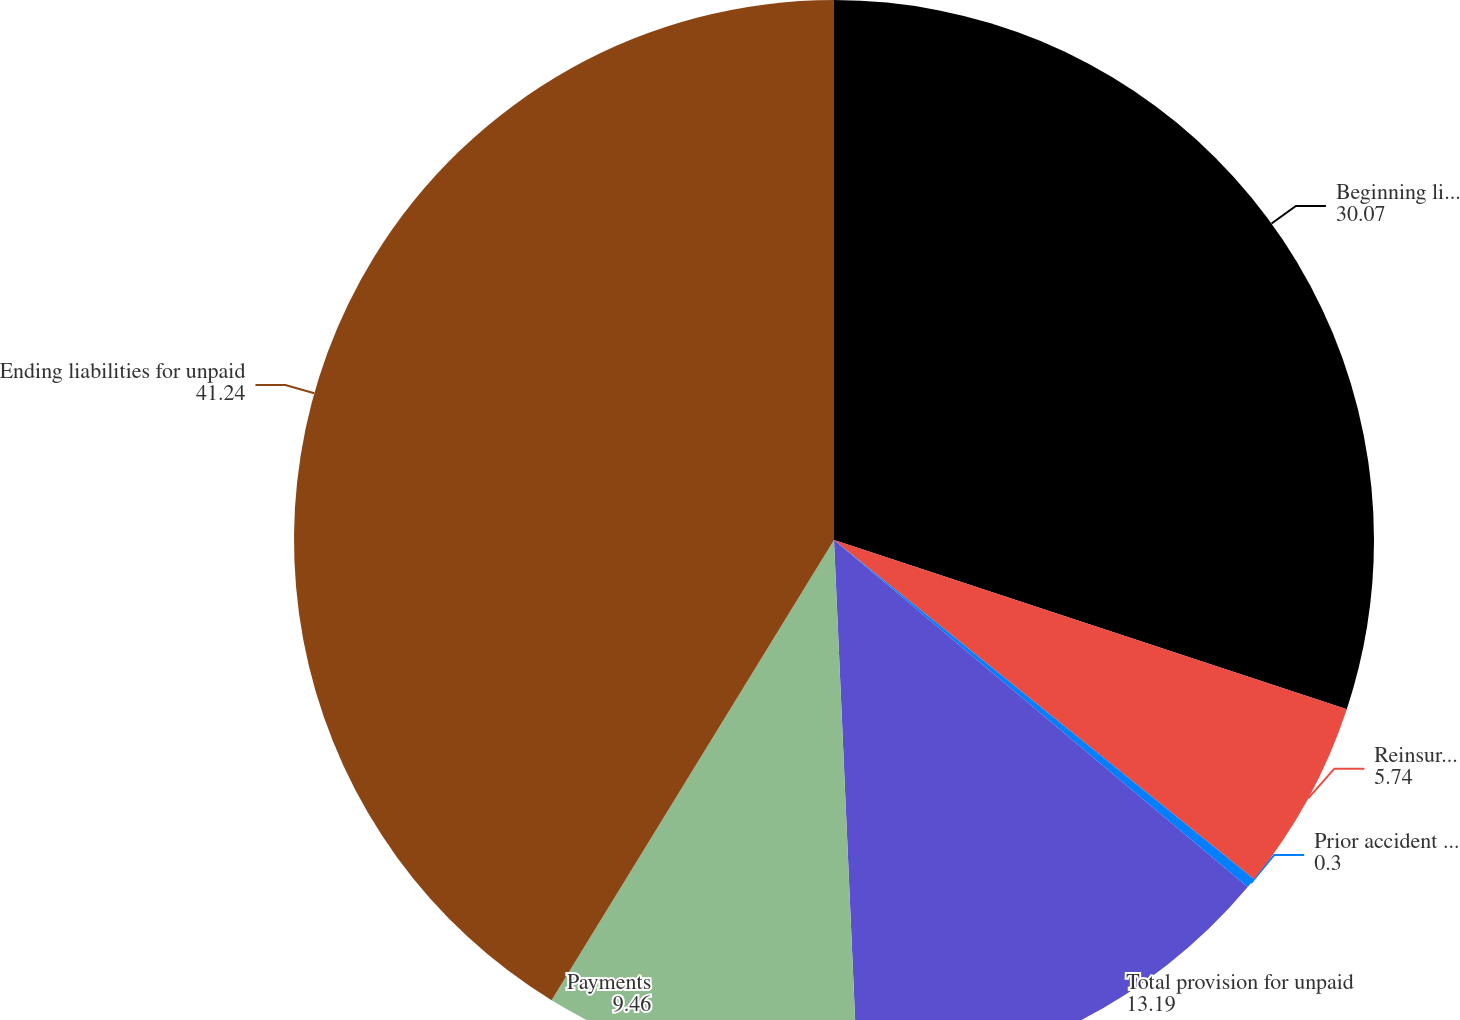Convert chart to OTSL. <chart><loc_0><loc_0><loc_500><loc_500><pie_chart><fcel>Beginning liabilities for<fcel>Reinsurance and other<fcel>Prior accident years<fcel>Total provision for unpaid<fcel>Payments<fcel>Ending liabilities for unpaid<nl><fcel>30.07%<fcel>5.74%<fcel>0.3%<fcel>13.19%<fcel>9.46%<fcel>41.24%<nl></chart> 